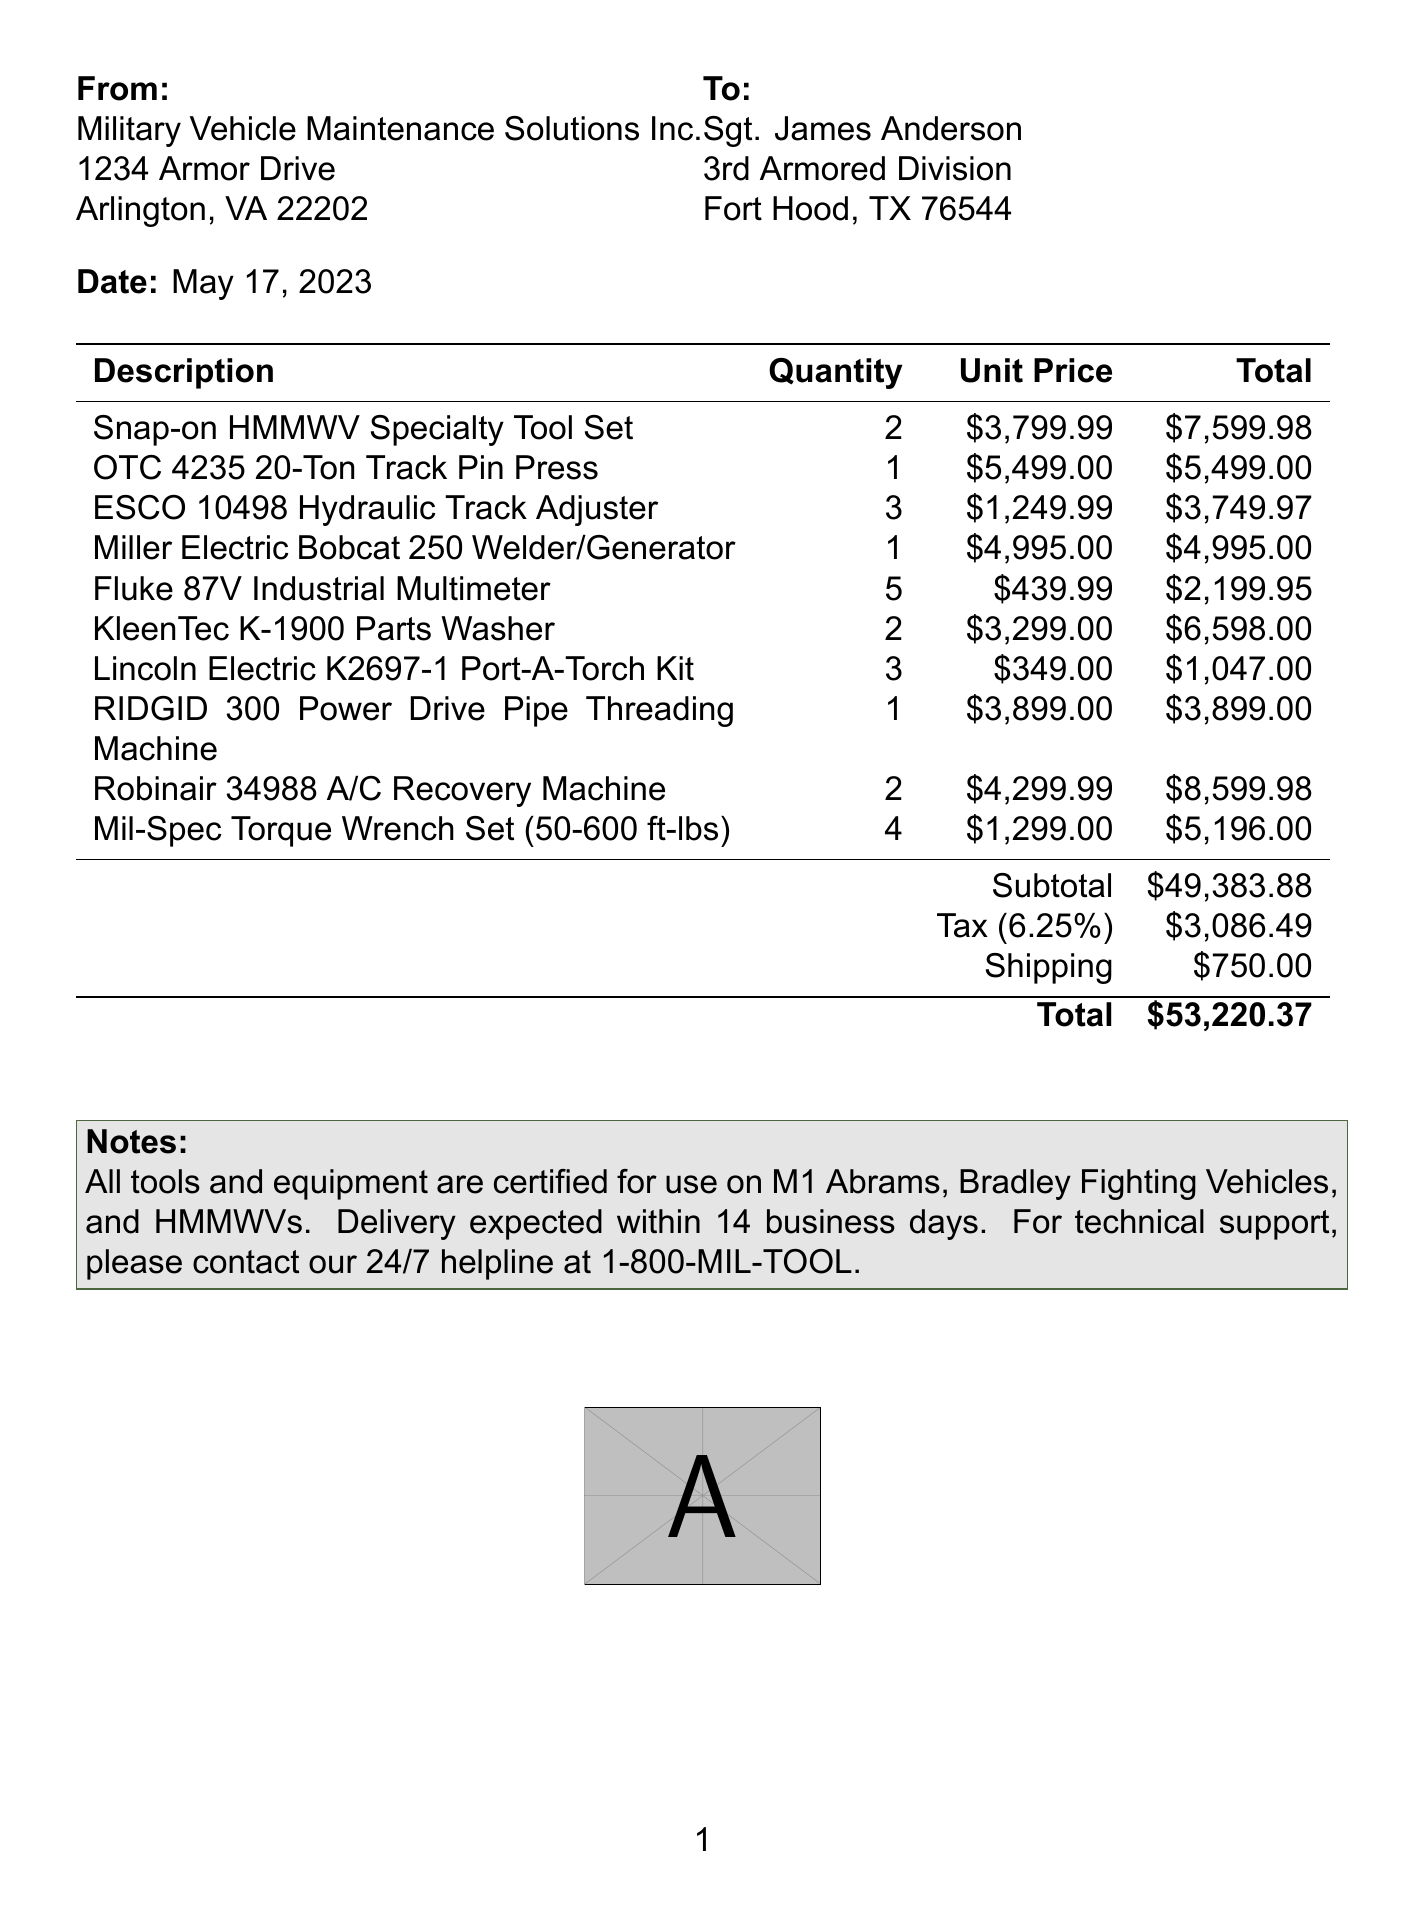what is the invoice number? The invoice number is stated at the top of the document and identifies this transaction as MV-2023-0517.
Answer: MV-2023-0517 who is the customer? The customer is listed in the document as Sgt. James Anderson from the 3rd Armored Division.
Answer: Sgt. James Anderson what is the total amount due? The total amount due is calculated by summing the subtotal, tax, and shipping costs presented in the invoice.
Answer: $53,220.37 how many Snap-on HMMWV Specialty Tool Sets were purchased? The document specifies that 2 units of the Snap-on HMMWV Specialty Tool Set were ordered.
Answer: 2 what is the subtotal before tax and shipping? The subtotal before tax and shipping is a line item shown in the invoice summarizing the cost of items.
Answer: $49,383.88 what is the tax rate applied to the invoice? The tax rate, mentioned explicitly in the document, represents the percentage applied to the subtotal for tax calculation.
Answer: 6.25% what equipment is certified for use on military vehicles? The notes section states that all tools and equipment listed are certified for use on specific military vehicles.
Answer: M1 Abrams, Bradley Fighting Vehicles, and HMMWVs how many Fluke 87V Industrial Multimeters were ordered? The document specifies that 5 units of Fluke 87V Industrial Multimeters were included in the order.
Answer: 5 who is the supplier? The supplier information is displayed prominently in the document and lists their name and address.
Answer: Military Vehicle Maintenance Solutions Inc 